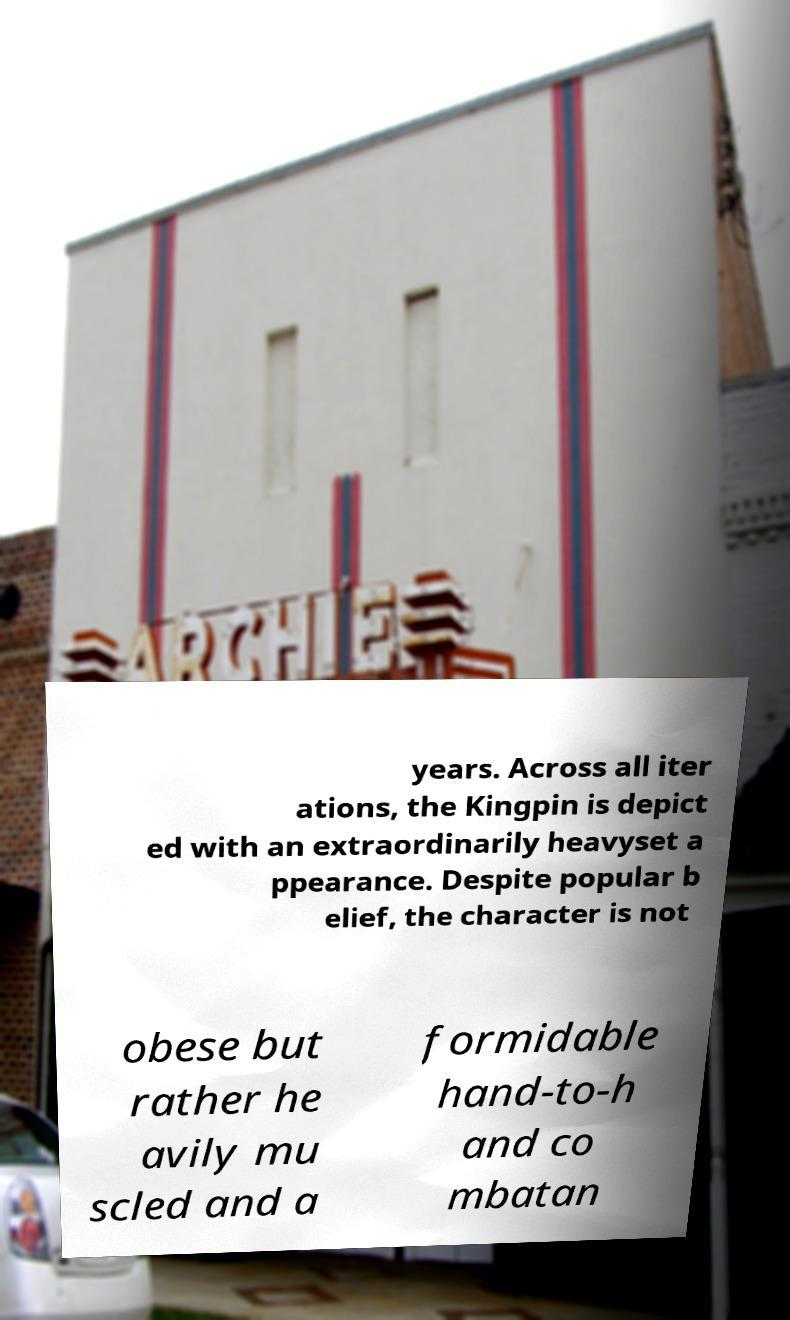Please read and relay the text visible in this image. What does it say? years. Across all iter ations, the Kingpin is depict ed with an extraordinarily heavyset a ppearance. Despite popular b elief, the character is not obese but rather he avily mu scled and a formidable hand-to-h and co mbatan 